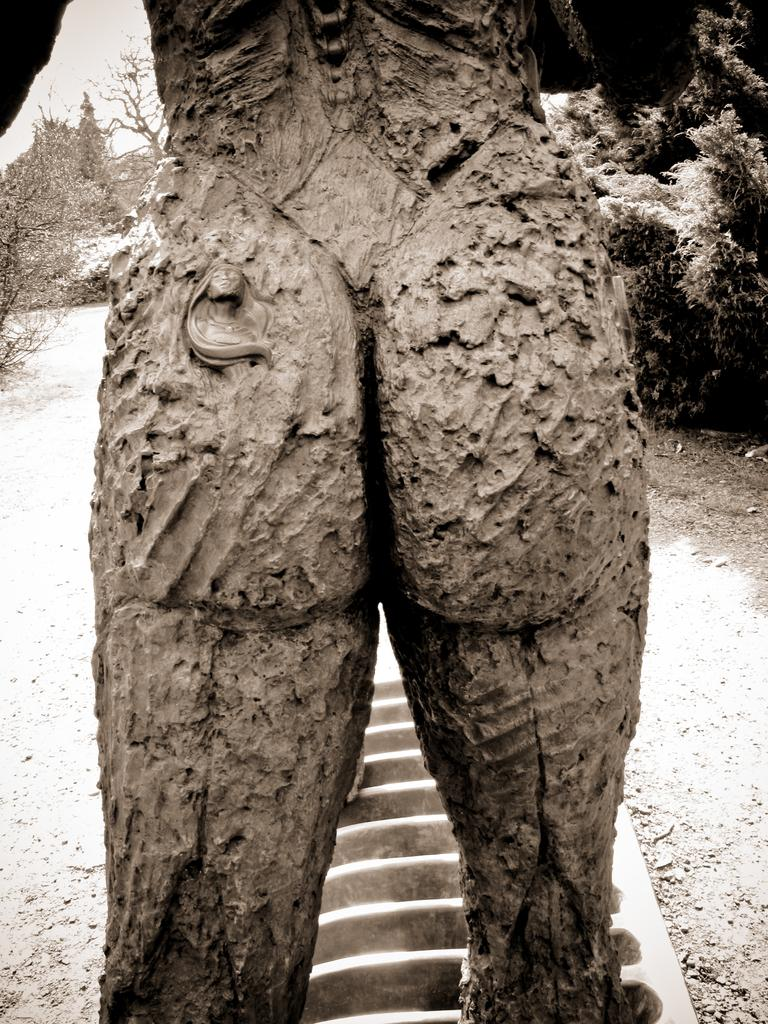What is the main subject of the image? There is a statue in the image. What material is the statue made of? The statue is made of mud. What can be seen in the vicinity of the statue? There are trees near the statue. What song is the statue singing in the image? There is no indication that the statue is singing a song in the image. 